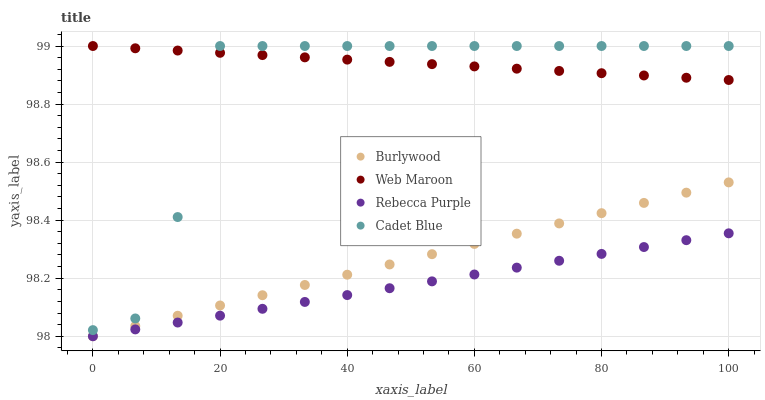Does Rebecca Purple have the minimum area under the curve?
Answer yes or no. Yes. Does Web Maroon have the maximum area under the curve?
Answer yes or no. Yes. Does Cadet Blue have the minimum area under the curve?
Answer yes or no. No. Does Cadet Blue have the maximum area under the curve?
Answer yes or no. No. Is Burlywood the smoothest?
Answer yes or no. Yes. Is Cadet Blue the roughest?
Answer yes or no. Yes. Is Web Maroon the smoothest?
Answer yes or no. No. Is Web Maroon the roughest?
Answer yes or no. No. Does Burlywood have the lowest value?
Answer yes or no. Yes. Does Cadet Blue have the lowest value?
Answer yes or no. No. Does Web Maroon have the highest value?
Answer yes or no. Yes. Does Rebecca Purple have the highest value?
Answer yes or no. No. Is Burlywood less than Web Maroon?
Answer yes or no. Yes. Is Cadet Blue greater than Rebecca Purple?
Answer yes or no. Yes. Does Web Maroon intersect Cadet Blue?
Answer yes or no. Yes. Is Web Maroon less than Cadet Blue?
Answer yes or no. No. Is Web Maroon greater than Cadet Blue?
Answer yes or no. No. Does Burlywood intersect Web Maroon?
Answer yes or no. No. 